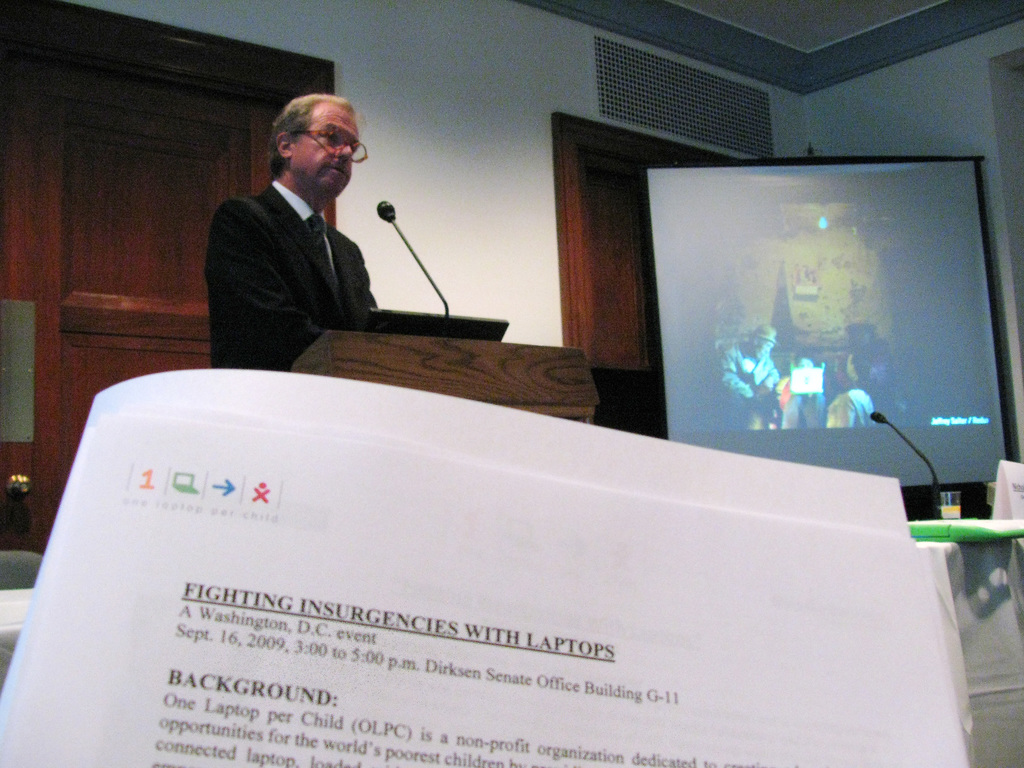Provide a one-sentence caption for the provided image. A man presents at a podium at an event titled 'Fighting insurgencies with laptops', part of a session by 'One Laptop per Child' (OLPC) aimed at exploring technological strategies to resolve conflicts, held at the Dirksen Senate Office Building on September 16, 2009. 